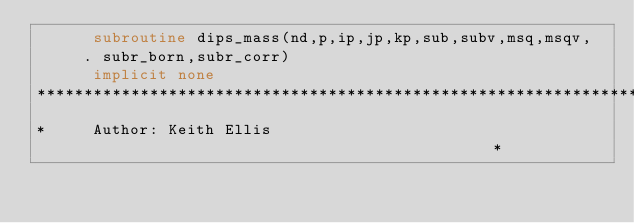Convert code to text. <code><loc_0><loc_0><loc_500><loc_500><_FORTRAN_>      subroutine dips_mass(nd,p,ip,jp,kp,sub,subv,msq,msqv,
     . subr_born,subr_corr)
      implicit none
************************************************************************
*     Author: Keith Ellis                                              *</code> 